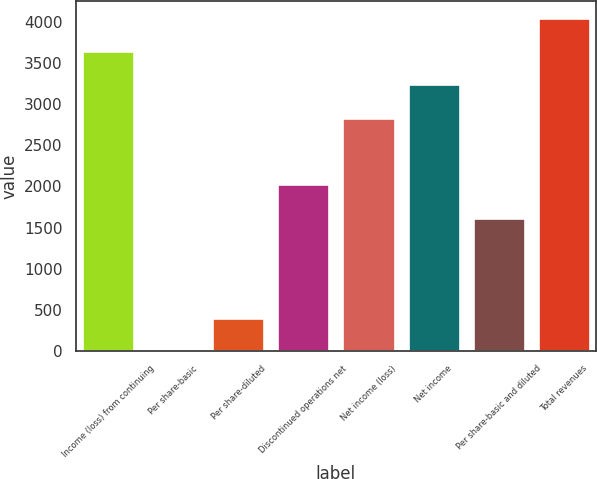Convert chart. <chart><loc_0><loc_0><loc_500><loc_500><bar_chart><fcel>Income (loss) from continuing<fcel>Per share-basic<fcel>Per share-diluted<fcel>Discontinued operations net<fcel>Net income (loss)<fcel>Net income<fcel>Per share-basic and diluted<fcel>Total revenues<nl><fcel>3646.91<fcel>0.2<fcel>405.39<fcel>2026.15<fcel>2836.53<fcel>3241.72<fcel>1620.96<fcel>4052.1<nl></chart> 